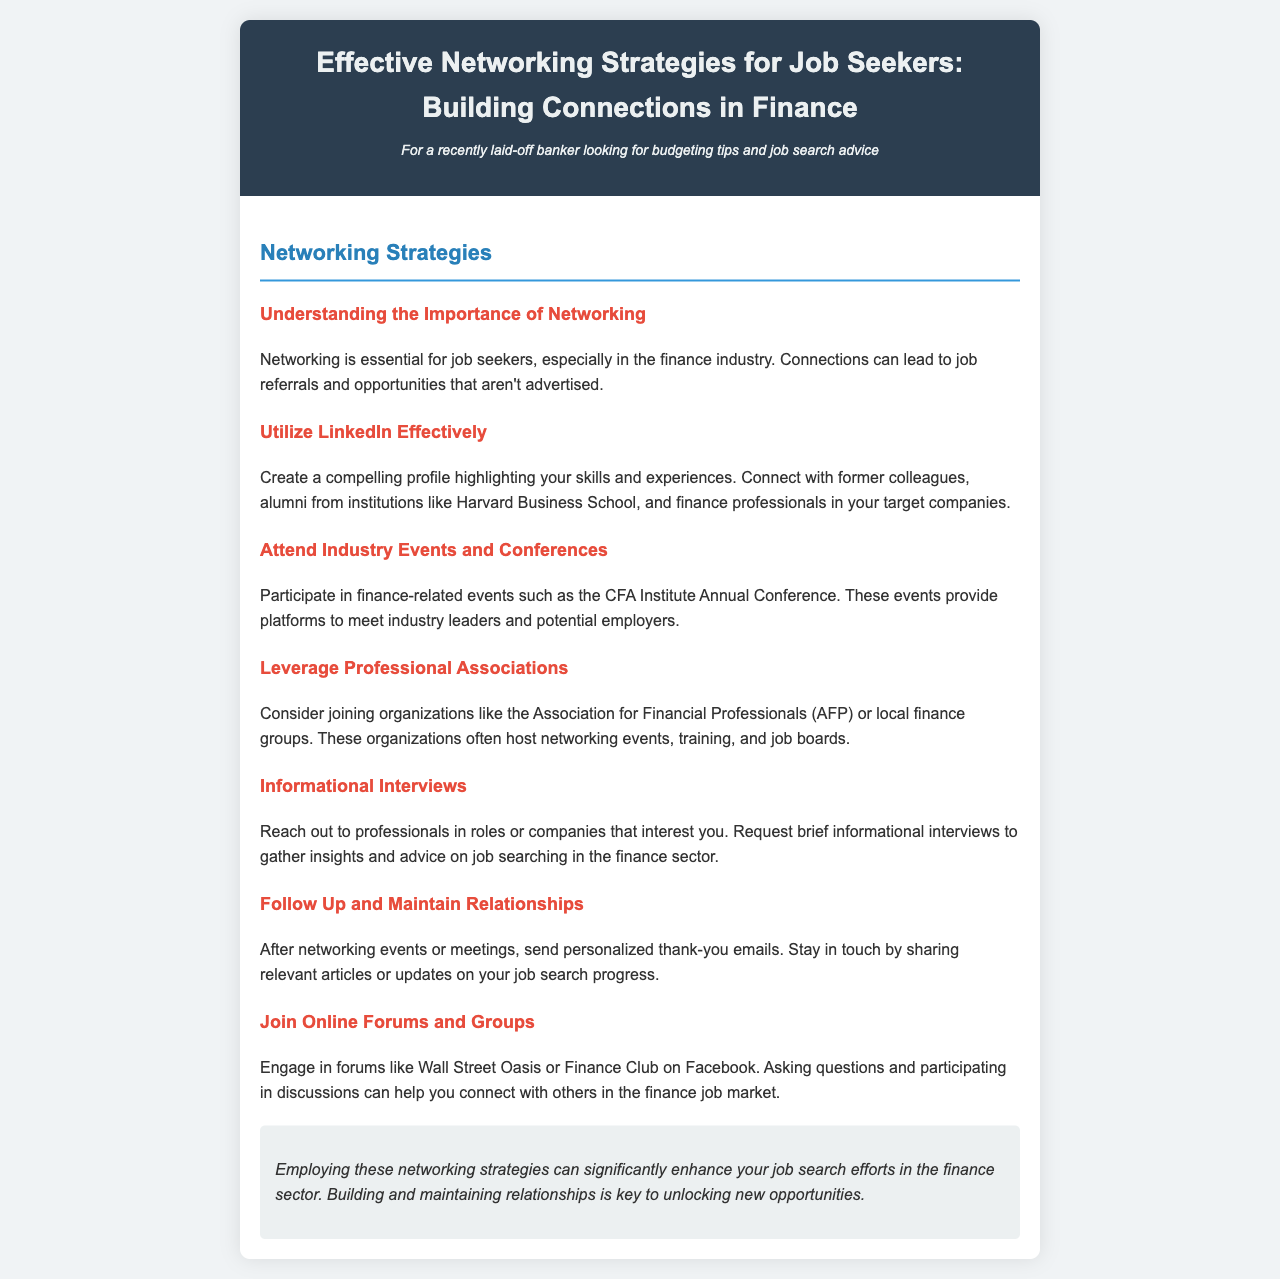What is the title of the brochure? The title of the brochure is stated at the top section of the document.
Answer: Effective Networking Strategies for Job Seekers: Building Connections in Finance What is a recommended professional association to join? The document lists organizations that can aid in networking, one of which is specified.
Answer: Association for Financial Professionals (AFP) What type of events should one attend for networking? The document suggests participating in certain events that are beneficial for networking in finance.
Answer: Industry events and conferences What is the primary purpose of informational interviews? The document explains that these interviews are for a specific type of engagement for job seekers.
Answer: To gather insights and advice Which online forums are suggested for engagement? The document mentions platforms where job seekers can connect with others in finance.
Answer: Wall Street Oasis Why is following up important after networking events? The document emphasizes the significance of staying in touch with connections made.
Answer: To maintain relationships What is the key outcome of employing networking strategies? The document concludes with the main benefit of using the suggested strategies.
Answer: Enhance job search efforts 